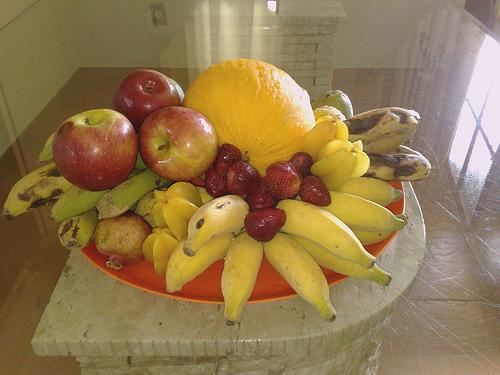How many strawberries are there?
Give a very brief answer. 8. 